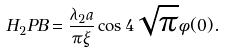Convert formula to latex. <formula><loc_0><loc_0><loc_500><loc_500>H _ { 2 } P B = \frac { \lambda _ { 2 } a } { \pi \xi } \cos 4 \sqrt { \pi } \phi ( 0 ) .</formula> 